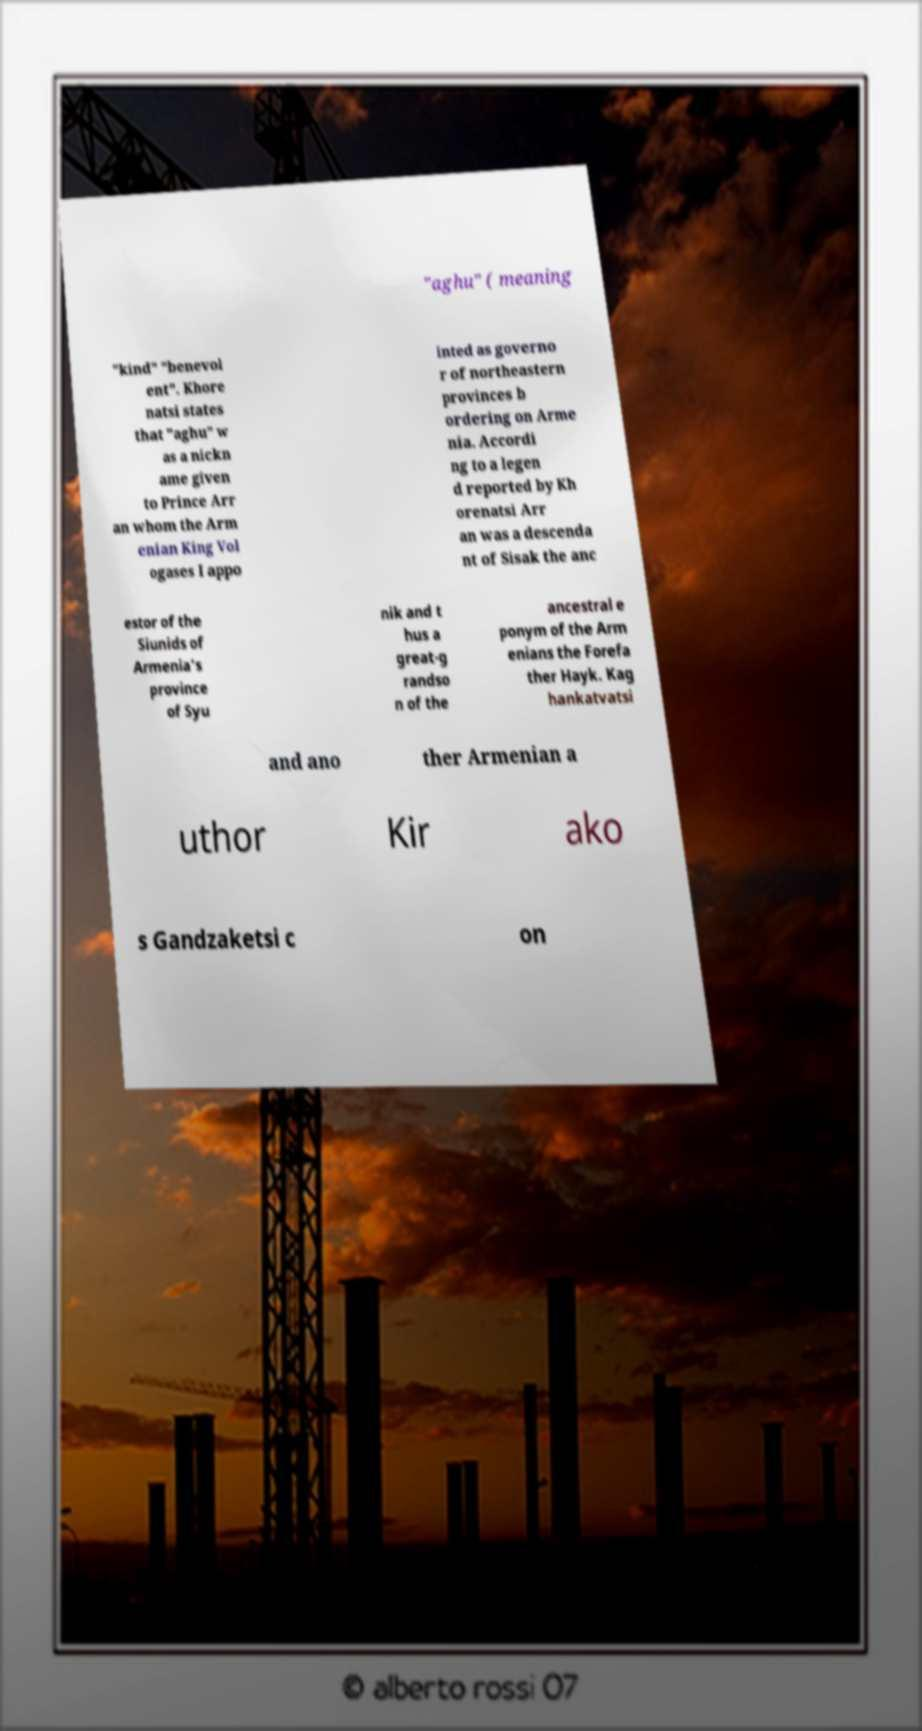I need the written content from this picture converted into text. Can you do that? "aghu" ( meaning "kind" "benevol ent". Khore natsi states that "aghu" w as a nickn ame given to Prince Arr an whom the Arm enian King Vol ogases I appo inted as governo r of northeastern provinces b ordering on Arme nia. Accordi ng to a legen d reported by Kh orenatsi Arr an was a descenda nt of Sisak the anc estor of the Siunids of Armenia's province of Syu nik and t hus a great-g randso n of the ancestral e ponym of the Arm enians the Forefa ther Hayk. Kag hankatvatsi and ano ther Armenian a uthor Kir ako s Gandzaketsi c on 